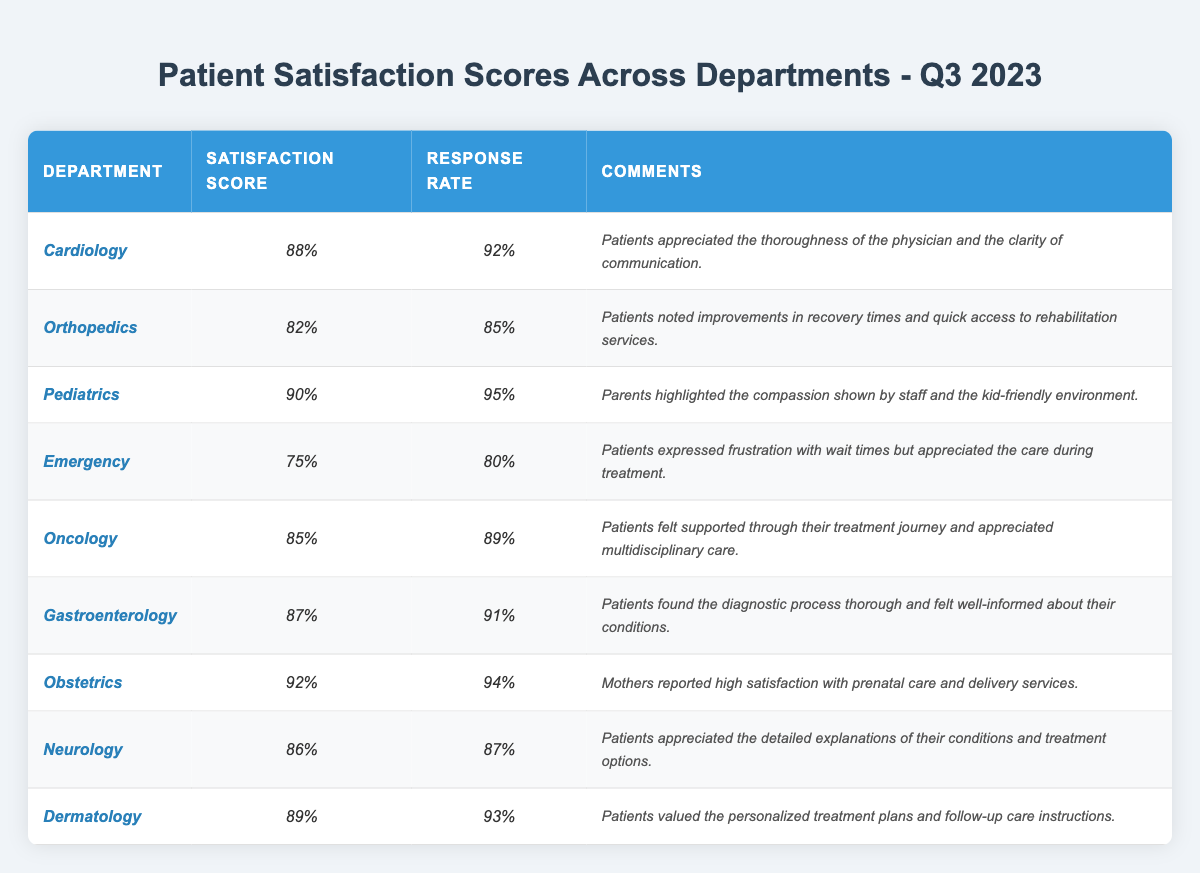What is the highest patient satisfaction score among the departments? From the table, the highest satisfaction score is located in the Obstetrics department with a score of 92%.
Answer: 92% Which department has the lowest response rate? By examining the table, the Emergency department has the lowest response rate of 80%.
Answer: 80% How many departments have a satisfaction score of 85% or higher? Counting the departments, we find that Cardiology, Pediatrics, Oncology, Gastroenterology, Obstetrics, Neurology, and Dermatology each have satisfaction scores at or above 85%. This gives us a total of 7 departments.
Answer: 7 What is the average satisfaction score of all the departments? To calculate the average: add the scores (88 + 82 + 90 + 75 + 85 + 87 + 92 + 86 + 89) = 88.67, and divide by 9 departments. Thus, the average satisfaction score rounds to approximately 87%.
Answer: 87% Is it true that more than half of the departments reported a satisfaction score below 85%? There are 9 departments in total, and only 2 (Orthopedics and Emergency) have scores below 85%. Since 2 is less than half of 9, the statement is false.
Answer: False Which department reported the highest response rate, and what was it? The response rates are checked to find that Pediatrics has the highest response rate at 95%.
Answer: 95% What percentage of departments achieved a satisfaction score of 90% or higher? There are 9 departments total. The ones with satisfaction scores of 90% or above are Pediatrics and Obstetrics (2 departments). Therefore, (2/9) * 100 = 22.22%, meaning about 22% of departments reached or exceeded 90%.
Answer: 22% How do patients in the Emergency department feel about their wait times? The comments from the Emergency department indicate patients expressed frustration regarding wait times, but they still appreciated the care received during treatment.
Answer: Frustration with wait times, but care appreciated Do most patients in the Oncology department feel supported during their treatment? The comments indicate that patients felt supported throughout their treatment journey in the Oncology department; thus, most patients hold a positive view about the support they received.
Answer: Yes, patients felt supported What is the difference in satisfaction scores between the highest and lowest scoring departments? Calculating the difference: 92% (Obstetrics) - 75% (Emergency) = 17%, showing that the highest department scores 17% higher than the lowest.
Answer: 17% 